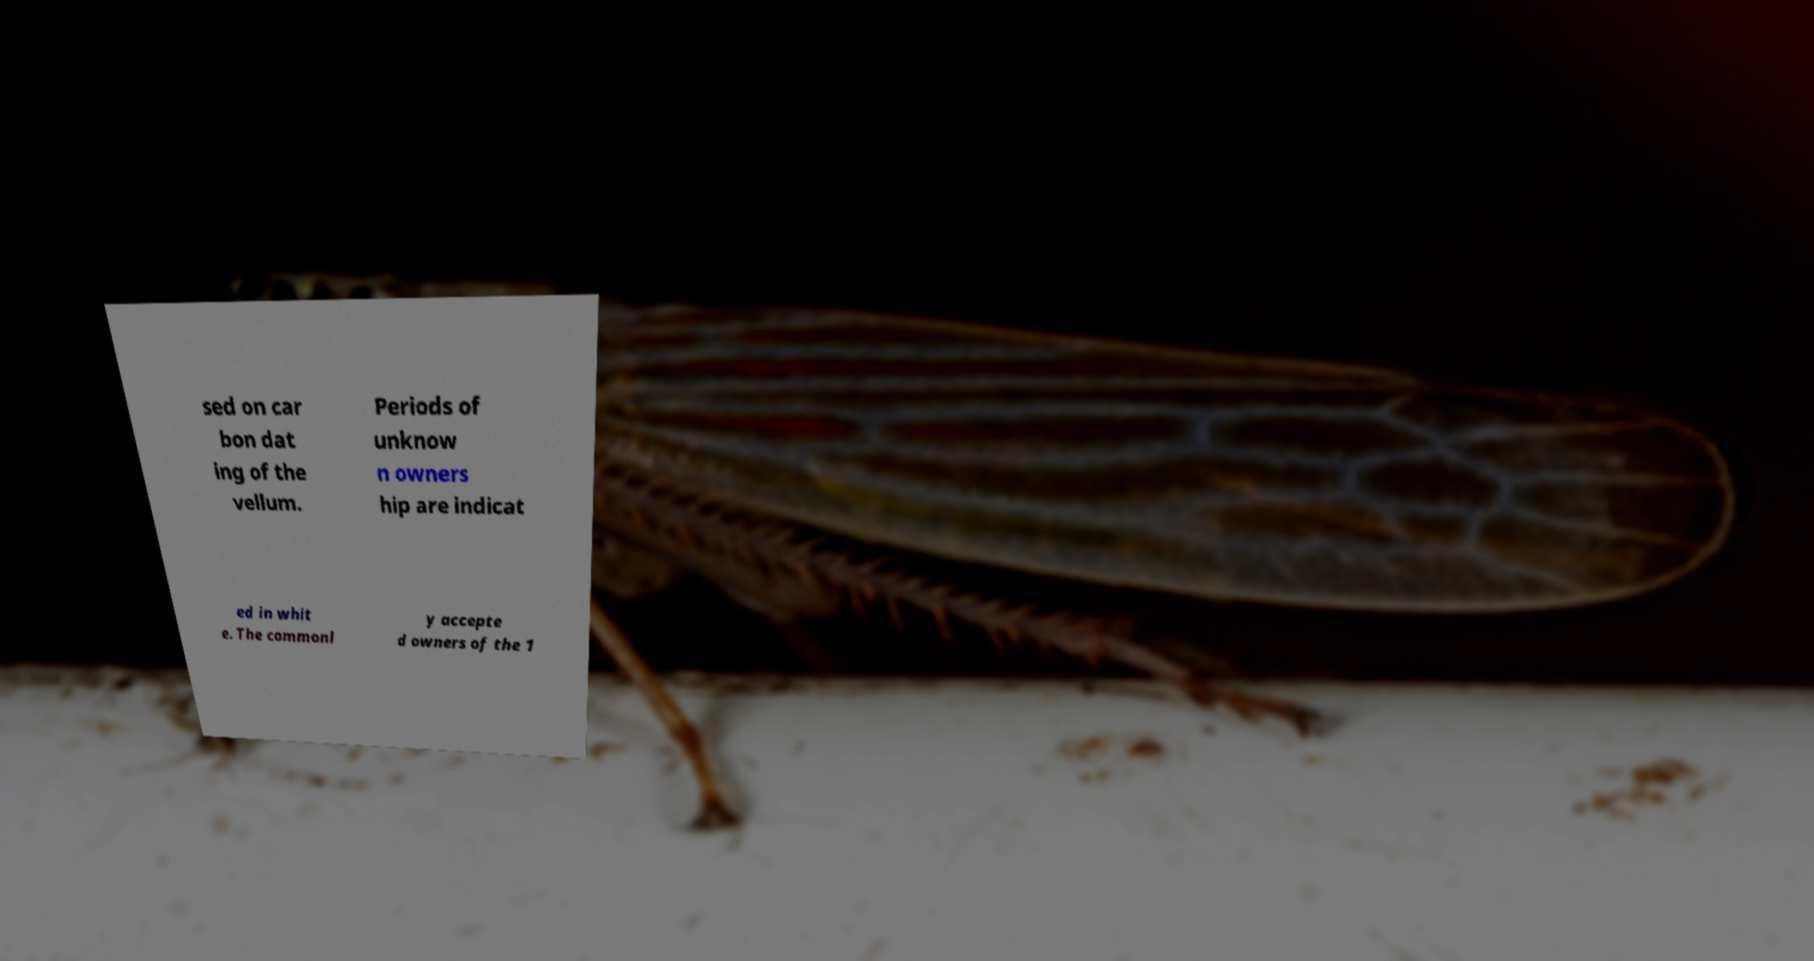Please read and relay the text visible in this image. What does it say? sed on car bon dat ing of the vellum. Periods of unknow n owners hip are indicat ed in whit e. The commonl y accepte d owners of the 1 